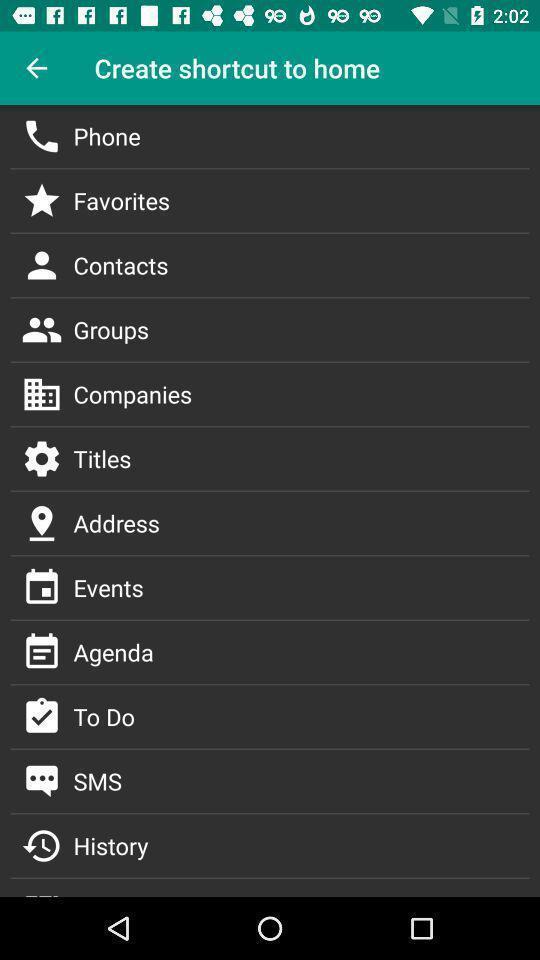Describe the content in this image. Set of options to create shortcut. 